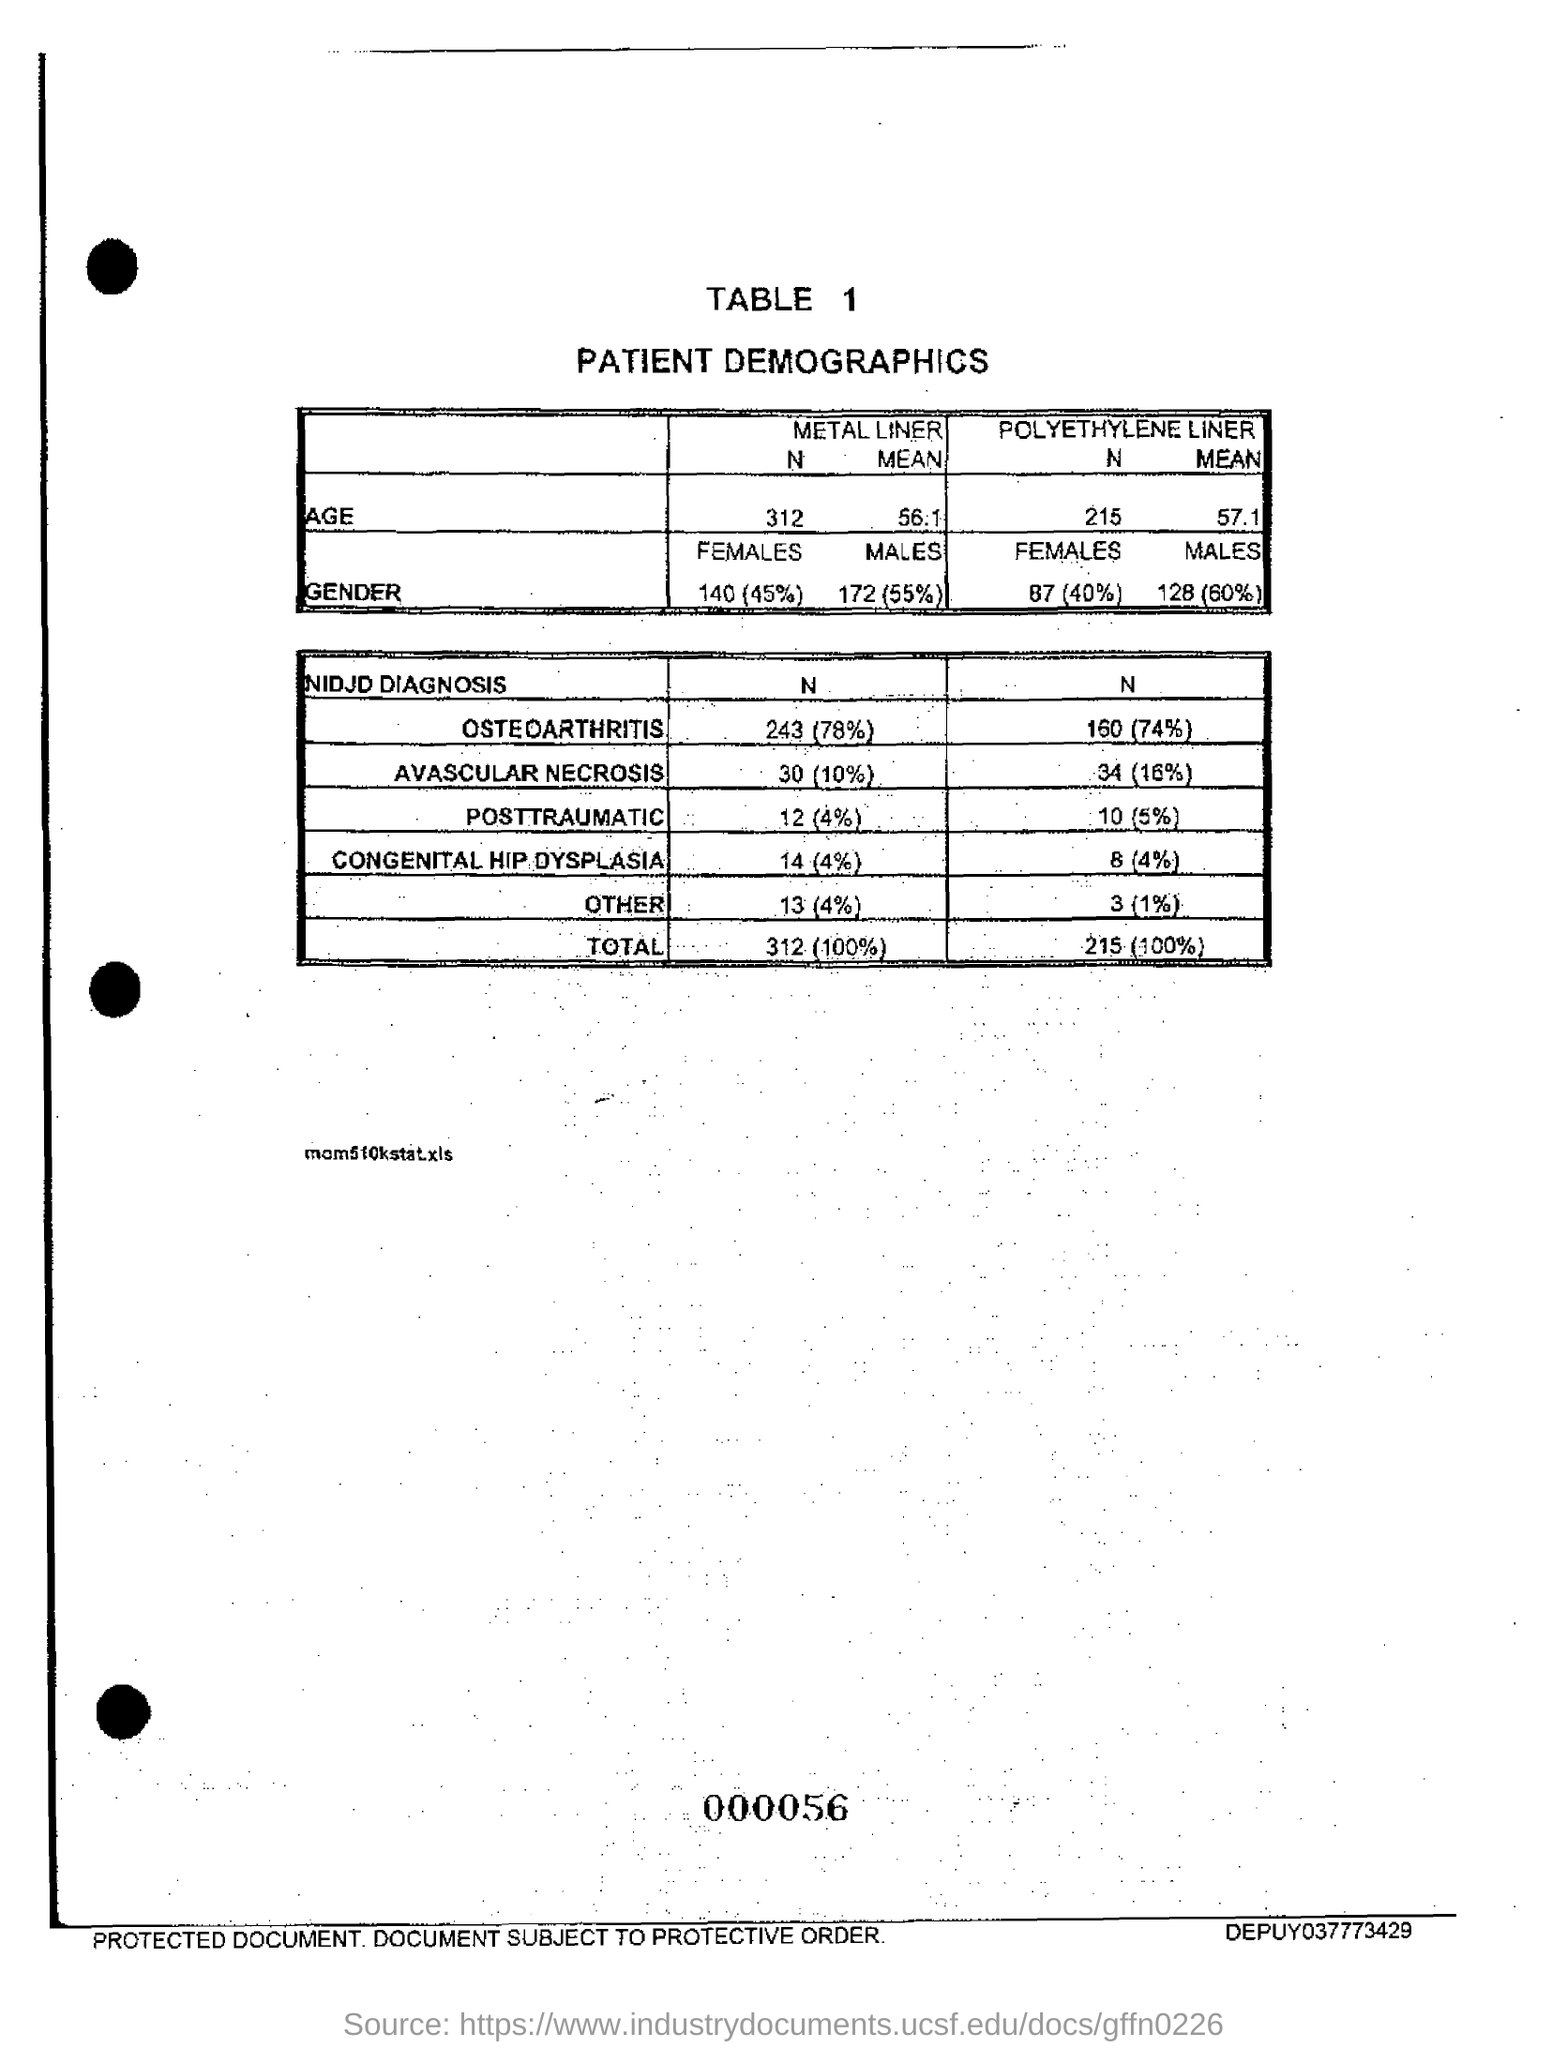What is the percentage of Osteoarthritis Patients with Metal Liner?
Ensure brevity in your answer.  78. 